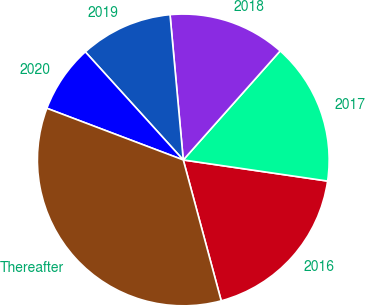Convert chart to OTSL. <chart><loc_0><loc_0><loc_500><loc_500><pie_chart><fcel>2016<fcel>2017<fcel>2018<fcel>2019<fcel>2020<fcel>Thereafter<nl><fcel>18.5%<fcel>15.75%<fcel>13.01%<fcel>10.27%<fcel>7.52%<fcel>34.95%<nl></chart> 